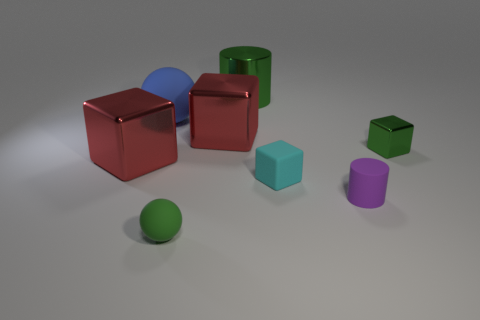There is a cylinder on the right side of the big green metal cylinder; what is it made of?
Keep it short and to the point. Rubber. Are there an equal number of purple cylinders that are right of the tiny green cube and tiny green metallic objects that are in front of the cyan rubber cube?
Offer a terse response. Yes. What is the color of the metallic thing that is the same shape as the purple rubber object?
Ensure brevity in your answer.  Green. Are there any other things that are the same color as the big matte thing?
Provide a short and direct response. No. What number of rubber objects are balls or green balls?
Provide a succinct answer. 2. Does the small matte ball have the same color as the large sphere?
Offer a very short reply. No. Are there more metal cubes that are on the left side of the tiny metallic object than large blocks?
Your answer should be very brief. No. What number of other things are made of the same material as the green cylinder?
Offer a terse response. 3. What number of large things are blue rubber balls or purple cylinders?
Your answer should be compact. 1. Does the big cylinder have the same material as the tiny green cube?
Your answer should be very brief. Yes. 